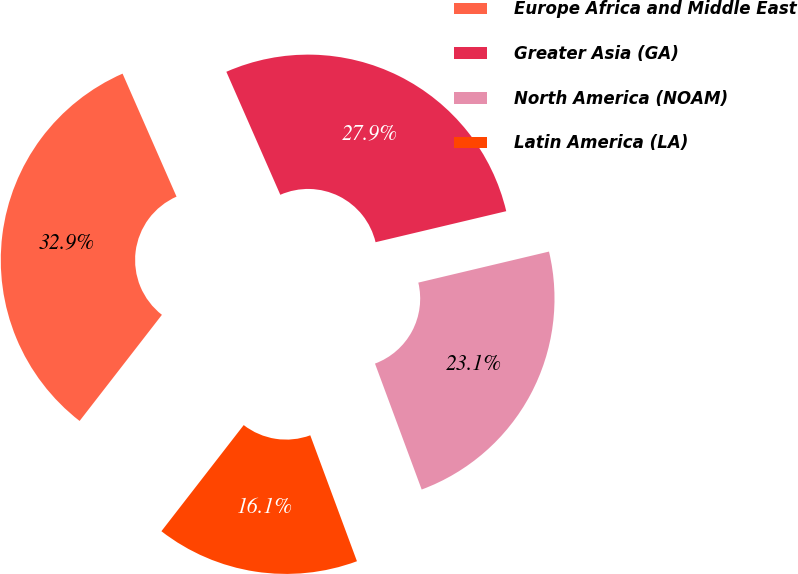<chart> <loc_0><loc_0><loc_500><loc_500><pie_chart><fcel>Europe Africa and Middle East<fcel>Greater Asia (GA)<fcel>North America (NOAM)<fcel>Latin America (LA)<nl><fcel>32.92%<fcel>27.87%<fcel>23.06%<fcel>16.15%<nl></chart> 